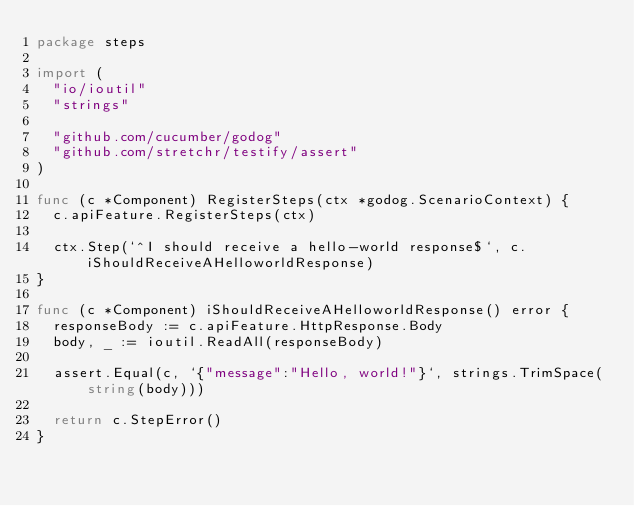Convert code to text. <code><loc_0><loc_0><loc_500><loc_500><_Go_>package steps

import (
	"io/ioutil"
	"strings"

	"github.com/cucumber/godog"
	"github.com/stretchr/testify/assert"
)

func (c *Component) RegisterSteps(ctx *godog.ScenarioContext) {
	c.apiFeature.RegisterSteps(ctx)

	ctx.Step(`^I should receive a hello-world response$`, c.iShouldReceiveAHelloworldResponse)
}

func (c *Component) iShouldReceiveAHelloworldResponse() error {
	responseBody := c.apiFeature.HttpResponse.Body
	body, _ := ioutil.ReadAll(responseBody)

	assert.Equal(c, `{"message":"Hello, world!"}`, strings.TrimSpace(string(body)))

	return c.StepError()
}
</code> 